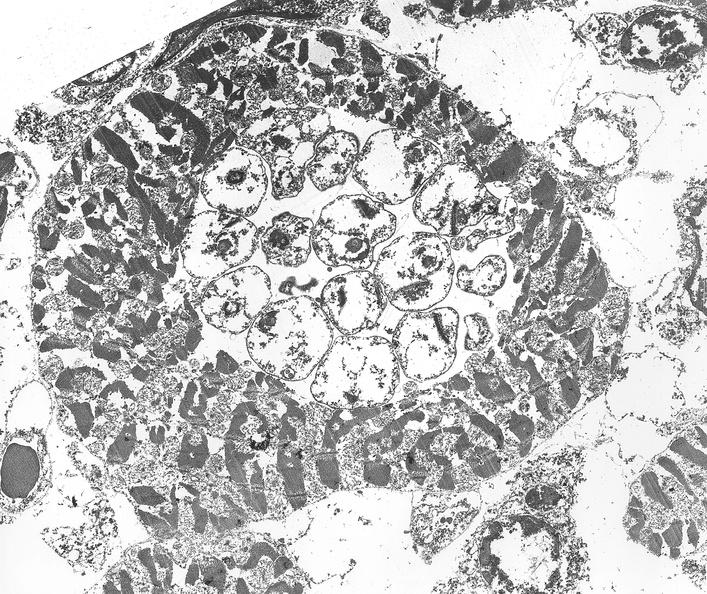what does this image show?
Answer the question using a single word or phrase. Chagas disease 